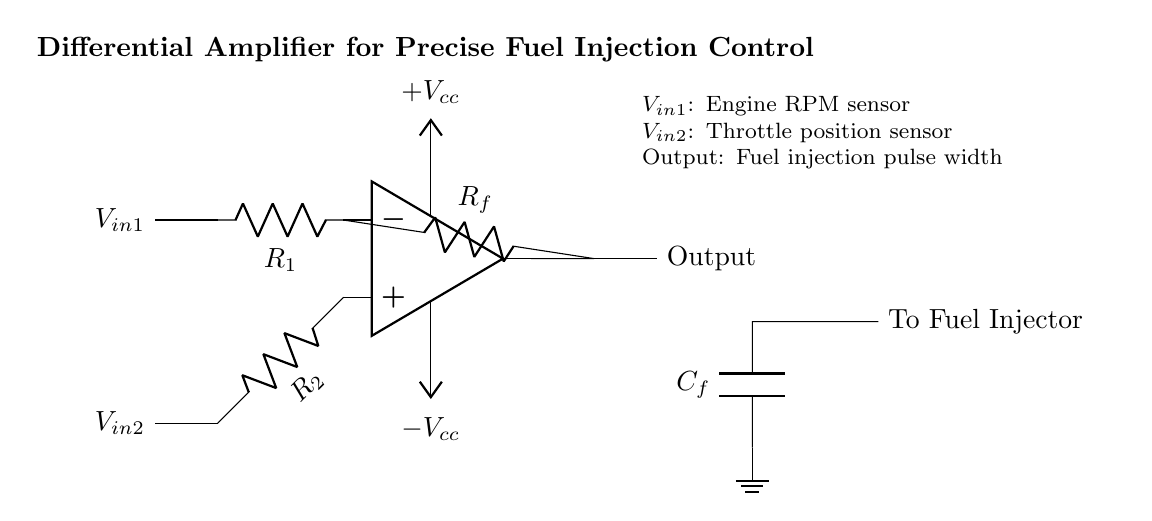What type of amplifier is shown? The circuit diagram illustrates a differential amplifier, which is designed to amplify the difference between two input signals. This type of amplifier isolates the output from the input voltage fluctuations of each source, making it suitable for precise applications like fuel injection control.
Answer: Differential amplifier What do the input resistors R1 and R2 do? R1 and R2 are input resistors that set the gain of the differential amplifier. They determine how much of each input signal (RPM sensor and throttle position sensor) is fed into the op-amp, and their values will affect the output voltage in response to the differences in these inputs.
Answer: Set gain What do V_in1 and V_in2 represent? V_in1 represents the input from the engine RPM sensor, while V_in2 represents the input from the throttle position sensor. These two signals are crucial for accurately controlling the fuel injection timing and duration based on engine performance.
Answer: Engine RPM sensor and Throttle position sensor What does the feedback resistor R_f do? The feedback resistor R_f provides feedback from the output back to the inverting input of the amplifier, allowing the amplifier to stabilize its gain and respond accurately to the changes in the input signals, ensuring precise control over the output.
Answer: Stabilizes gain What is the purpose of the capacitor C_f? C_f acts as a filter capacitor that smooths out the output signal before it is sent to the fuel injector. This filtering reduces noise and provides a cleaner pulse width, enhancing the performance and response of the fuel injection system.
Answer: Smoothens output What is the output labeled as? The output is labeled simply as 'Output', indicating that it carries the resulting fuel injection pulse width signal derived from the amplified difference between the two input voltage signals. This pulse width will ultimately trigger the fuel injector.
Answer: Output 